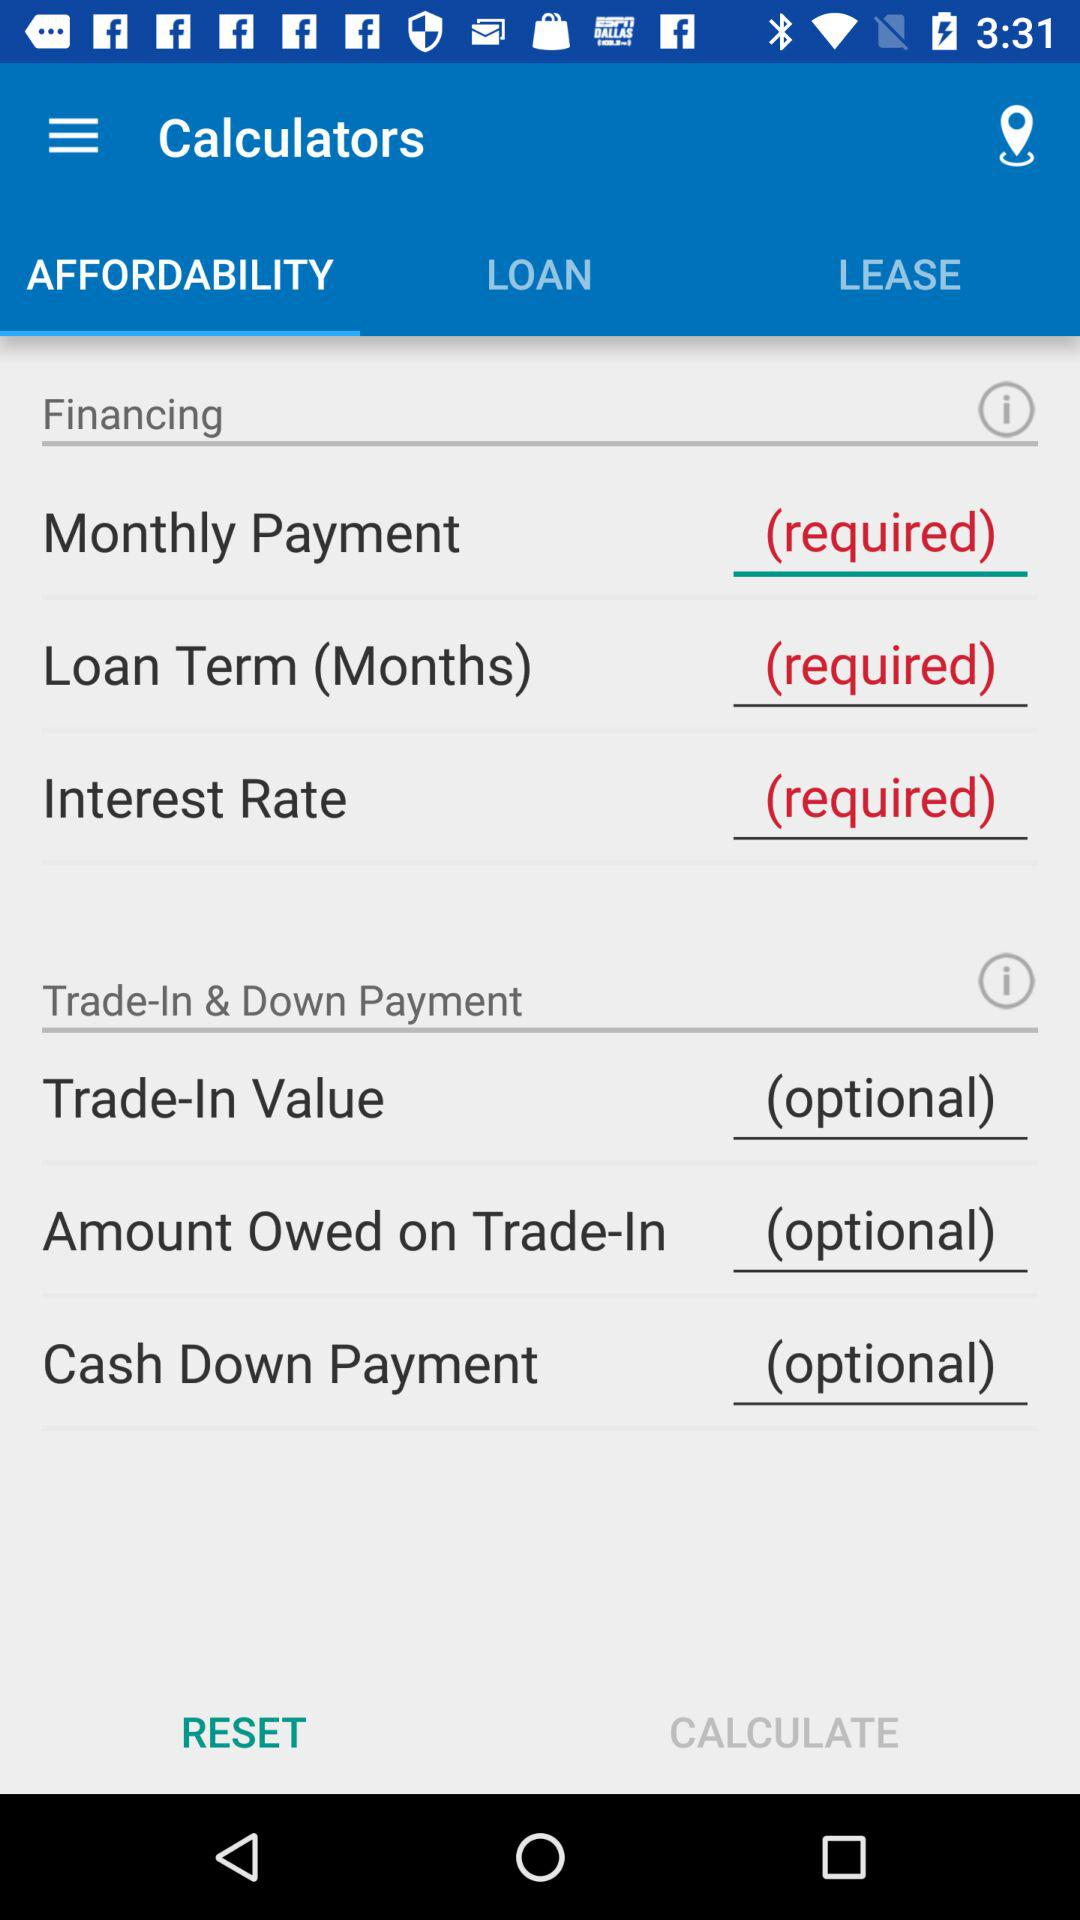How much is the trade-in value?
When the provided information is insufficient, respond with <no answer>. <no answer> 